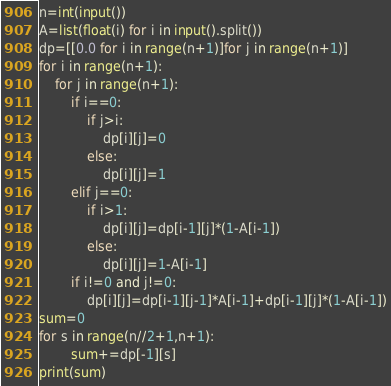Convert code to text. <code><loc_0><loc_0><loc_500><loc_500><_Python_>n=int(input())
A=list(float(i) for i in input().split())
dp=[[0.0 for i in range(n+1)]for j in range(n+1)]
for i in range(n+1):
    for j in range(n+1):
        if i==0:
            if j>i:
                dp[i][j]=0
            else:
                dp[i][j]=1
        elif j==0:
            if i>1:
                dp[i][j]=dp[i-1][j]*(1-A[i-1])
            else:
                dp[i][j]=1-A[i-1]
        if i!=0 and j!=0:
            dp[i][j]=dp[i-1][j-1]*A[i-1]+dp[i-1][j]*(1-A[i-1])
sum=0
for s in range(n//2+1,n+1):
        sum+=dp[-1][s]
print(sum)
</code> 